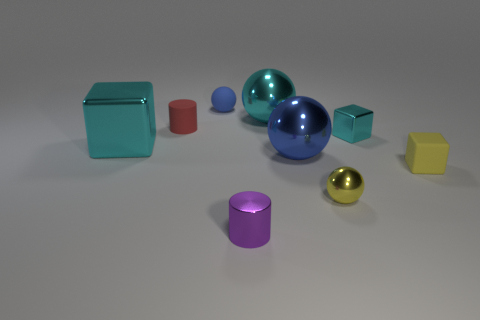What color is the tiny metallic cube?
Your answer should be compact. Cyan. Is there another tiny object of the same shape as the tiny red matte thing?
Make the answer very short. Yes. There is a blue matte object that is the same size as the red thing; what is its shape?
Your answer should be compact. Sphere. What is the shape of the cyan metal object that is in front of the shiny object right of the yellow thing in front of the small rubber block?
Provide a short and direct response. Cube. There is a red matte thing; is it the same shape as the tiny shiny thing left of the big cyan metal sphere?
Give a very brief answer. Yes. What number of small objects are red things or balls?
Offer a very short reply. 3. Is there a metallic block that has the same size as the cyan sphere?
Offer a very short reply. Yes. What is the color of the big shiny ball that is on the right side of the big sphere behind the blue thing on the right side of the purple cylinder?
Offer a very short reply. Blue. Are the tiny purple cylinder and the large blue sphere right of the large cyan metal block made of the same material?
Your answer should be very brief. Yes. There is a purple thing that is the same shape as the red thing; what size is it?
Your response must be concise. Small. 